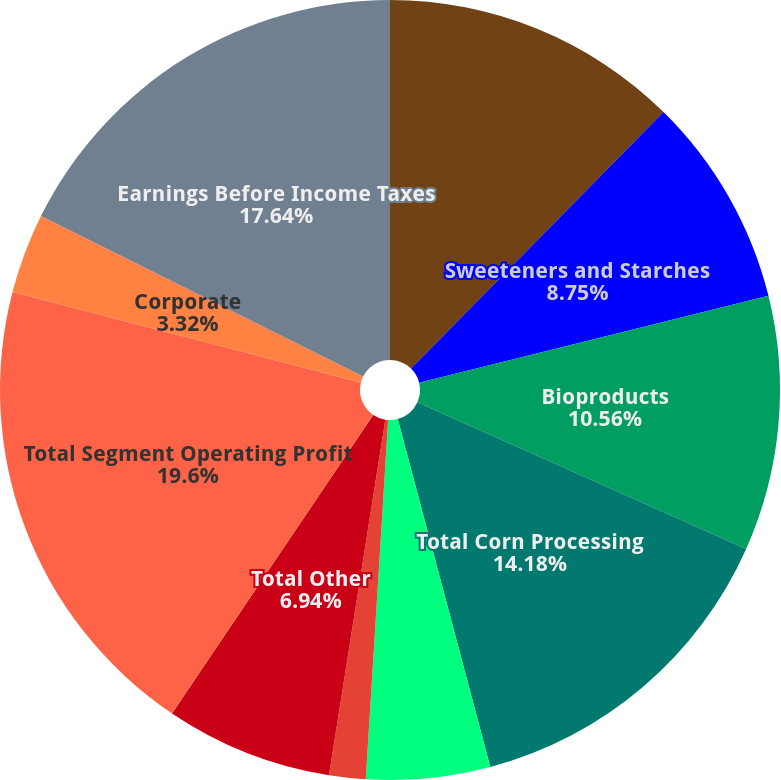Convert chart. <chart><loc_0><loc_0><loc_500><loc_500><pie_chart><fcel>Oilseeds Processing<fcel>Sweeteners and Starches<fcel>Bioproducts<fcel>Total Corn Processing<fcel>Agricultural Services<fcel>Food Feed and Industrial<fcel>Total Other<fcel>Total Segment Operating Profit<fcel>Corporate<fcel>Earnings Before Income Taxes<nl><fcel>12.37%<fcel>8.75%<fcel>10.56%<fcel>14.18%<fcel>5.13%<fcel>1.51%<fcel>6.94%<fcel>19.6%<fcel>3.32%<fcel>17.64%<nl></chart> 